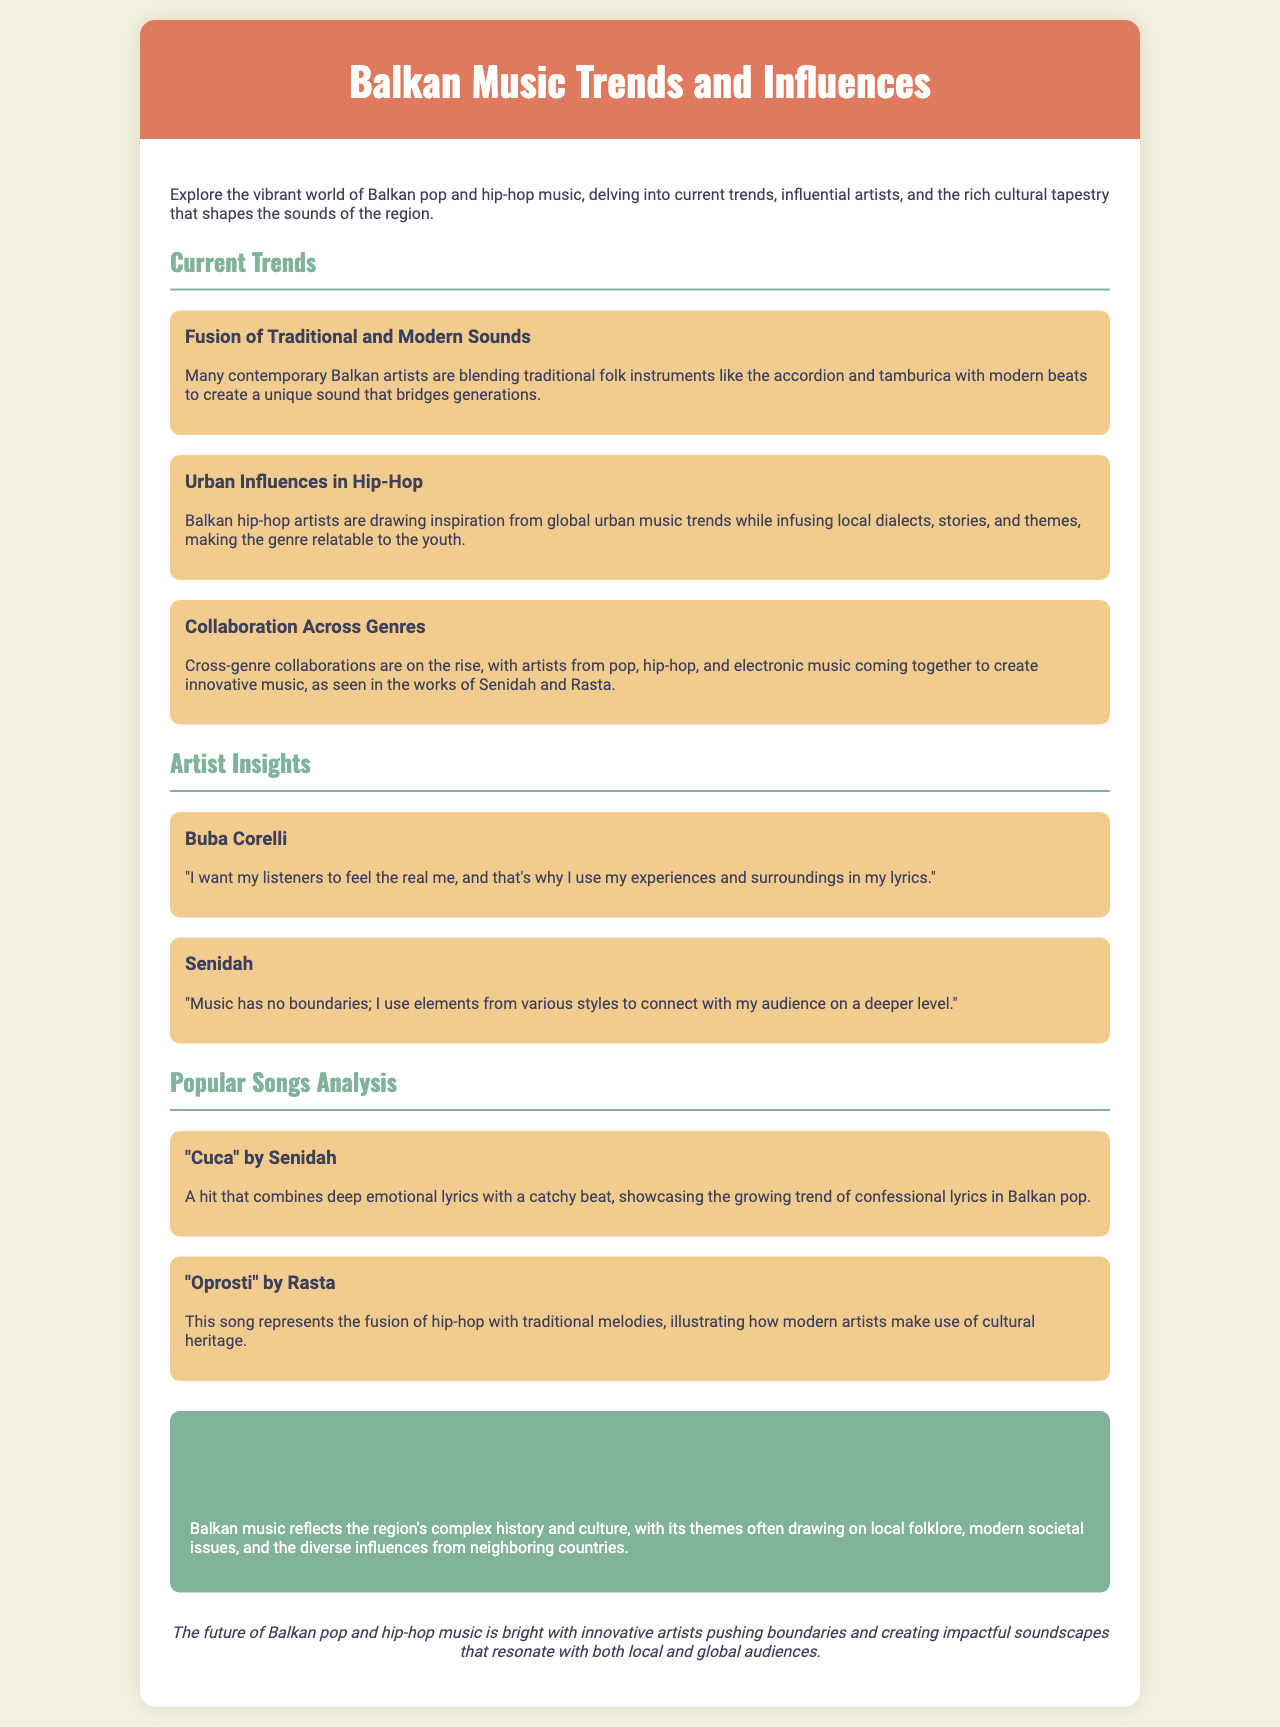What is the title of the brochure? The title is prominently displayed at the top of the document, which introduces the main theme of the content.
Answer: Balkan Music Trends and Influences Who is a featured artist in the interviews section? The document lists several influential artists, specifically mentioning their names prominently in the interview sections.
Answer: Buba Corelli What song is analyzed that is by Senidah? The document provides the titles of popular songs analyzed under a specific section dedicated to song analysis.
Answer: "Cuca" What is the main cultural element reflected in Balkan music? The brochure describes how music reflects various aspects of the region's identity, which includes influences from its diverse history.
Answer: Local folklore How does Buba Corelli describe his music? The content shared by the artist mentions his intent behind creating music through his personal experiences.
Answer: Real me What trend involves blending different genres? The document highlights a growing trend among artists collaborating across various music styles.
Answer: Cross-genre collaborations What color is used for the cultural impact section? The brochure uses specific colors to visually distinguish different sections, making it identifiable.
Answer: Green Which instrument is mentioned in relation to traditional music? The document references specific instruments that are commonly used in contemporary Balkan music.
Answer: Accordion 